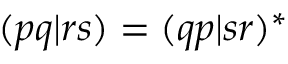Convert formula to latex. <formula><loc_0><loc_0><loc_500><loc_500>( p q | r s ) = ( q p | s r ) ^ { * }</formula> 